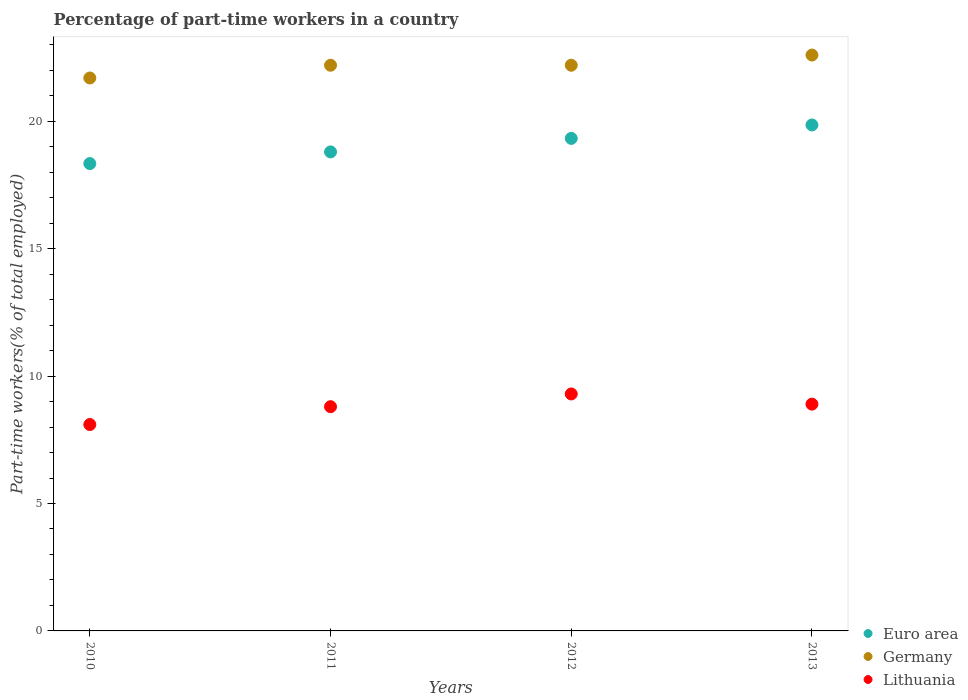How many different coloured dotlines are there?
Provide a succinct answer. 3. What is the percentage of part-time workers in Euro area in 2010?
Provide a succinct answer. 18.34. Across all years, what is the maximum percentage of part-time workers in Lithuania?
Offer a very short reply. 9.3. Across all years, what is the minimum percentage of part-time workers in Euro area?
Provide a succinct answer. 18.34. In which year was the percentage of part-time workers in Euro area maximum?
Your answer should be compact. 2013. What is the total percentage of part-time workers in Germany in the graph?
Offer a very short reply. 88.7. What is the difference between the percentage of part-time workers in Euro area in 2012 and that in 2013?
Your response must be concise. -0.53. What is the difference between the percentage of part-time workers in Lithuania in 2011 and the percentage of part-time workers in Euro area in 2010?
Your answer should be very brief. -9.54. What is the average percentage of part-time workers in Lithuania per year?
Offer a very short reply. 8.78. In the year 2012, what is the difference between the percentage of part-time workers in Lithuania and percentage of part-time workers in Euro area?
Provide a succinct answer. -10.03. In how many years, is the percentage of part-time workers in Lithuania greater than 12 %?
Offer a very short reply. 0. What is the ratio of the percentage of part-time workers in Germany in 2011 to that in 2013?
Your answer should be compact. 0.98. Is the difference between the percentage of part-time workers in Lithuania in 2012 and 2013 greater than the difference between the percentage of part-time workers in Euro area in 2012 and 2013?
Keep it short and to the point. Yes. What is the difference between the highest and the second highest percentage of part-time workers in Germany?
Your response must be concise. 0.4. What is the difference between the highest and the lowest percentage of part-time workers in Lithuania?
Give a very brief answer. 1.2. In how many years, is the percentage of part-time workers in Euro area greater than the average percentage of part-time workers in Euro area taken over all years?
Offer a very short reply. 2. Does the percentage of part-time workers in Germany monotonically increase over the years?
Provide a short and direct response. No. Is the percentage of part-time workers in Lithuania strictly greater than the percentage of part-time workers in Euro area over the years?
Your answer should be very brief. No. Is the percentage of part-time workers in Lithuania strictly less than the percentage of part-time workers in Germany over the years?
Your answer should be compact. Yes. How many dotlines are there?
Make the answer very short. 3. How many years are there in the graph?
Offer a terse response. 4. Does the graph contain any zero values?
Your answer should be compact. No. Does the graph contain grids?
Give a very brief answer. No. How are the legend labels stacked?
Provide a short and direct response. Vertical. What is the title of the graph?
Provide a succinct answer. Percentage of part-time workers in a country. What is the label or title of the Y-axis?
Give a very brief answer. Part-time workers(% of total employed). What is the Part-time workers(% of total employed) in Euro area in 2010?
Your answer should be compact. 18.34. What is the Part-time workers(% of total employed) of Germany in 2010?
Your response must be concise. 21.7. What is the Part-time workers(% of total employed) in Lithuania in 2010?
Offer a terse response. 8.1. What is the Part-time workers(% of total employed) in Euro area in 2011?
Your response must be concise. 18.8. What is the Part-time workers(% of total employed) in Germany in 2011?
Give a very brief answer. 22.2. What is the Part-time workers(% of total employed) in Lithuania in 2011?
Provide a short and direct response. 8.8. What is the Part-time workers(% of total employed) of Euro area in 2012?
Make the answer very short. 19.33. What is the Part-time workers(% of total employed) in Germany in 2012?
Provide a short and direct response. 22.2. What is the Part-time workers(% of total employed) in Lithuania in 2012?
Offer a terse response. 9.3. What is the Part-time workers(% of total employed) in Euro area in 2013?
Your answer should be compact. 19.86. What is the Part-time workers(% of total employed) in Germany in 2013?
Keep it short and to the point. 22.6. What is the Part-time workers(% of total employed) in Lithuania in 2013?
Your answer should be compact. 8.9. Across all years, what is the maximum Part-time workers(% of total employed) in Euro area?
Provide a succinct answer. 19.86. Across all years, what is the maximum Part-time workers(% of total employed) of Germany?
Your answer should be compact. 22.6. Across all years, what is the maximum Part-time workers(% of total employed) of Lithuania?
Keep it short and to the point. 9.3. Across all years, what is the minimum Part-time workers(% of total employed) of Euro area?
Provide a short and direct response. 18.34. Across all years, what is the minimum Part-time workers(% of total employed) of Germany?
Make the answer very short. 21.7. Across all years, what is the minimum Part-time workers(% of total employed) of Lithuania?
Provide a succinct answer. 8.1. What is the total Part-time workers(% of total employed) of Euro area in the graph?
Your response must be concise. 76.33. What is the total Part-time workers(% of total employed) of Germany in the graph?
Keep it short and to the point. 88.7. What is the total Part-time workers(% of total employed) in Lithuania in the graph?
Make the answer very short. 35.1. What is the difference between the Part-time workers(% of total employed) of Euro area in 2010 and that in 2011?
Ensure brevity in your answer.  -0.46. What is the difference between the Part-time workers(% of total employed) in Euro area in 2010 and that in 2012?
Provide a short and direct response. -0.99. What is the difference between the Part-time workers(% of total employed) in Germany in 2010 and that in 2012?
Ensure brevity in your answer.  -0.5. What is the difference between the Part-time workers(% of total employed) of Lithuania in 2010 and that in 2012?
Your response must be concise. -1.2. What is the difference between the Part-time workers(% of total employed) of Euro area in 2010 and that in 2013?
Provide a succinct answer. -1.52. What is the difference between the Part-time workers(% of total employed) of Germany in 2010 and that in 2013?
Give a very brief answer. -0.9. What is the difference between the Part-time workers(% of total employed) of Lithuania in 2010 and that in 2013?
Provide a succinct answer. -0.8. What is the difference between the Part-time workers(% of total employed) of Euro area in 2011 and that in 2012?
Your response must be concise. -0.53. What is the difference between the Part-time workers(% of total employed) in Lithuania in 2011 and that in 2012?
Your answer should be very brief. -0.5. What is the difference between the Part-time workers(% of total employed) of Euro area in 2011 and that in 2013?
Keep it short and to the point. -1.06. What is the difference between the Part-time workers(% of total employed) of Euro area in 2012 and that in 2013?
Give a very brief answer. -0.53. What is the difference between the Part-time workers(% of total employed) in Lithuania in 2012 and that in 2013?
Provide a short and direct response. 0.4. What is the difference between the Part-time workers(% of total employed) of Euro area in 2010 and the Part-time workers(% of total employed) of Germany in 2011?
Give a very brief answer. -3.86. What is the difference between the Part-time workers(% of total employed) of Euro area in 2010 and the Part-time workers(% of total employed) of Lithuania in 2011?
Ensure brevity in your answer.  9.54. What is the difference between the Part-time workers(% of total employed) of Euro area in 2010 and the Part-time workers(% of total employed) of Germany in 2012?
Keep it short and to the point. -3.86. What is the difference between the Part-time workers(% of total employed) in Euro area in 2010 and the Part-time workers(% of total employed) in Lithuania in 2012?
Offer a very short reply. 9.04. What is the difference between the Part-time workers(% of total employed) of Germany in 2010 and the Part-time workers(% of total employed) of Lithuania in 2012?
Provide a succinct answer. 12.4. What is the difference between the Part-time workers(% of total employed) in Euro area in 2010 and the Part-time workers(% of total employed) in Germany in 2013?
Your response must be concise. -4.26. What is the difference between the Part-time workers(% of total employed) in Euro area in 2010 and the Part-time workers(% of total employed) in Lithuania in 2013?
Ensure brevity in your answer.  9.44. What is the difference between the Part-time workers(% of total employed) of Euro area in 2011 and the Part-time workers(% of total employed) of Germany in 2012?
Your response must be concise. -3.4. What is the difference between the Part-time workers(% of total employed) in Euro area in 2011 and the Part-time workers(% of total employed) in Lithuania in 2012?
Provide a succinct answer. 9.5. What is the difference between the Part-time workers(% of total employed) of Euro area in 2011 and the Part-time workers(% of total employed) of Germany in 2013?
Provide a short and direct response. -3.8. What is the difference between the Part-time workers(% of total employed) in Euro area in 2011 and the Part-time workers(% of total employed) in Lithuania in 2013?
Provide a short and direct response. 9.9. What is the difference between the Part-time workers(% of total employed) in Euro area in 2012 and the Part-time workers(% of total employed) in Germany in 2013?
Keep it short and to the point. -3.27. What is the difference between the Part-time workers(% of total employed) in Euro area in 2012 and the Part-time workers(% of total employed) in Lithuania in 2013?
Your answer should be very brief. 10.43. What is the average Part-time workers(% of total employed) of Euro area per year?
Your answer should be very brief. 19.08. What is the average Part-time workers(% of total employed) of Germany per year?
Offer a very short reply. 22.18. What is the average Part-time workers(% of total employed) of Lithuania per year?
Offer a very short reply. 8.78. In the year 2010, what is the difference between the Part-time workers(% of total employed) of Euro area and Part-time workers(% of total employed) of Germany?
Your response must be concise. -3.36. In the year 2010, what is the difference between the Part-time workers(% of total employed) of Euro area and Part-time workers(% of total employed) of Lithuania?
Offer a terse response. 10.24. In the year 2011, what is the difference between the Part-time workers(% of total employed) in Euro area and Part-time workers(% of total employed) in Germany?
Offer a very short reply. -3.4. In the year 2011, what is the difference between the Part-time workers(% of total employed) in Euro area and Part-time workers(% of total employed) in Lithuania?
Provide a short and direct response. 10. In the year 2012, what is the difference between the Part-time workers(% of total employed) of Euro area and Part-time workers(% of total employed) of Germany?
Provide a succinct answer. -2.87. In the year 2012, what is the difference between the Part-time workers(% of total employed) of Euro area and Part-time workers(% of total employed) of Lithuania?
Offer a very short reply. 10.03. In the year 2012, what is the difference between the Part-time workers(% of total employed) of Germany and Part-time workers(% of total employed) of Lithuania?
Give a very brief answer. 12.9. In the year 2013, what is the difference between the Part-time workers(% of total employed) in Euro area and Part-time workers(% of total employed) in Germany?
Your answer should be very brief. -2.74. In the year 2013, what is the difference between the Part-time workers(% of total employed) in Euro area and Part-time workers(% of total employed) in Lithuania?
Provide a short and direct response. 10.96. In the year 2013, what is the difference between the Part-time workers(% of total employed) in Germany and Part-time workers(% of total employed) in Lithuania?
Give a very brief answer. 13.7. What is the ratio of the Part-time workers(% of total employed) of Euro area in 2010 to that in 2011?
Provide a succinct answer. 0.98. What is the ratio of the Part-time workers(% of total employed) in Germany in 2010 to that in 2011?
Offer a very short reply. 0.98. What is the ratio of the Part-time workers(% of total employed) in Lithuania in 2010 to that in 2011?
Give a very brief answer. 0.92. What is the ratio of the Part-time workers(% of total employed) in Euro area in 2010 to that in 2012?
Keep it short and to the point. 0.95. What is the ratio of the Part-time workers(% of total employed) of Germany in 2010 to that in 2012?
Your answer should be very brief. 0.98. What is the ratio of the Part-time workers(% of total employed) of Lithuania in 2010 to that in 2012?
Provide a succinct answer. 0.87. What is the ratio of the Part-time workers(% of total employed) in Euro area in 2010 to that in 2013?
Ensure brevity in your answer.  0.92. What is the ratio of the Part-time workers(% of total employed) in Germany in 2010 to that in 2013?
Provide a succinct answer. 0.96. What is the ratio of the Part-time workers(% of total employed) of Lithuania in 2010 to that in 2013?
Offer a very short reply. 0.91. What is the ratio of the Part-time workers(% of total employed) of Euro area in 2011 to that in 2012?
Ensure brevity in your answer.  0.97. What is the ratio of the Part-time workers(% of total employed) of Germany in 2011 to that in 2012?
Provide a succinct answer. 1. What is the ratio of the Part-time workers(% of total employed) of Lithuania in 2011 to that in 2012?
Offer a terse response. 0.95. What is the ratio of the Part-time workers(% of total employed) of Euro area in 2011 to that in 2013?
Your response must be concise. 0.95. What is the ratio of the Part-time workers(% of total employed) in Germany in 2011 to that in 2013?
Your answer should be very brief. 0.98. What is the ratio of the Part-time workers(% of total employed) in Lithuania in 2011 to that in 2013?
Keep it short and to the point. 0.99. What is the ratio of the Part-time workers(% of total employed) in Euro area in 2012 to that in 2013?
Provide a short and direct response. 0.97. What is the ratio of the Part-time workers(% of total employed) of Germany in 2012 to that in 2013?
Keep it short and to the point. 0.98. What is the ratio of the Part-time workers(% of total employed) in Lithuania in 2012 to that in 2013?
Offer a terse response. 1.04. What is the difference between the highest and the second highest Part-time workers(% of total employed) in Euro area?
Ensure brevity in your answer.  0.53. What is the difference between the highest and the second highest Part-time workers(% of total employed) in Germany?
Make the answer very short. 0.4. What is the difference between the highest and the lowest Part-time workers(% of total employed) of Euro area?
Your response must be concise. 1.52. What is the difference between the highest and the lowest Part-time workers(% of total employed) of Lithuania?
Your answer should be very brief. 1.2. 